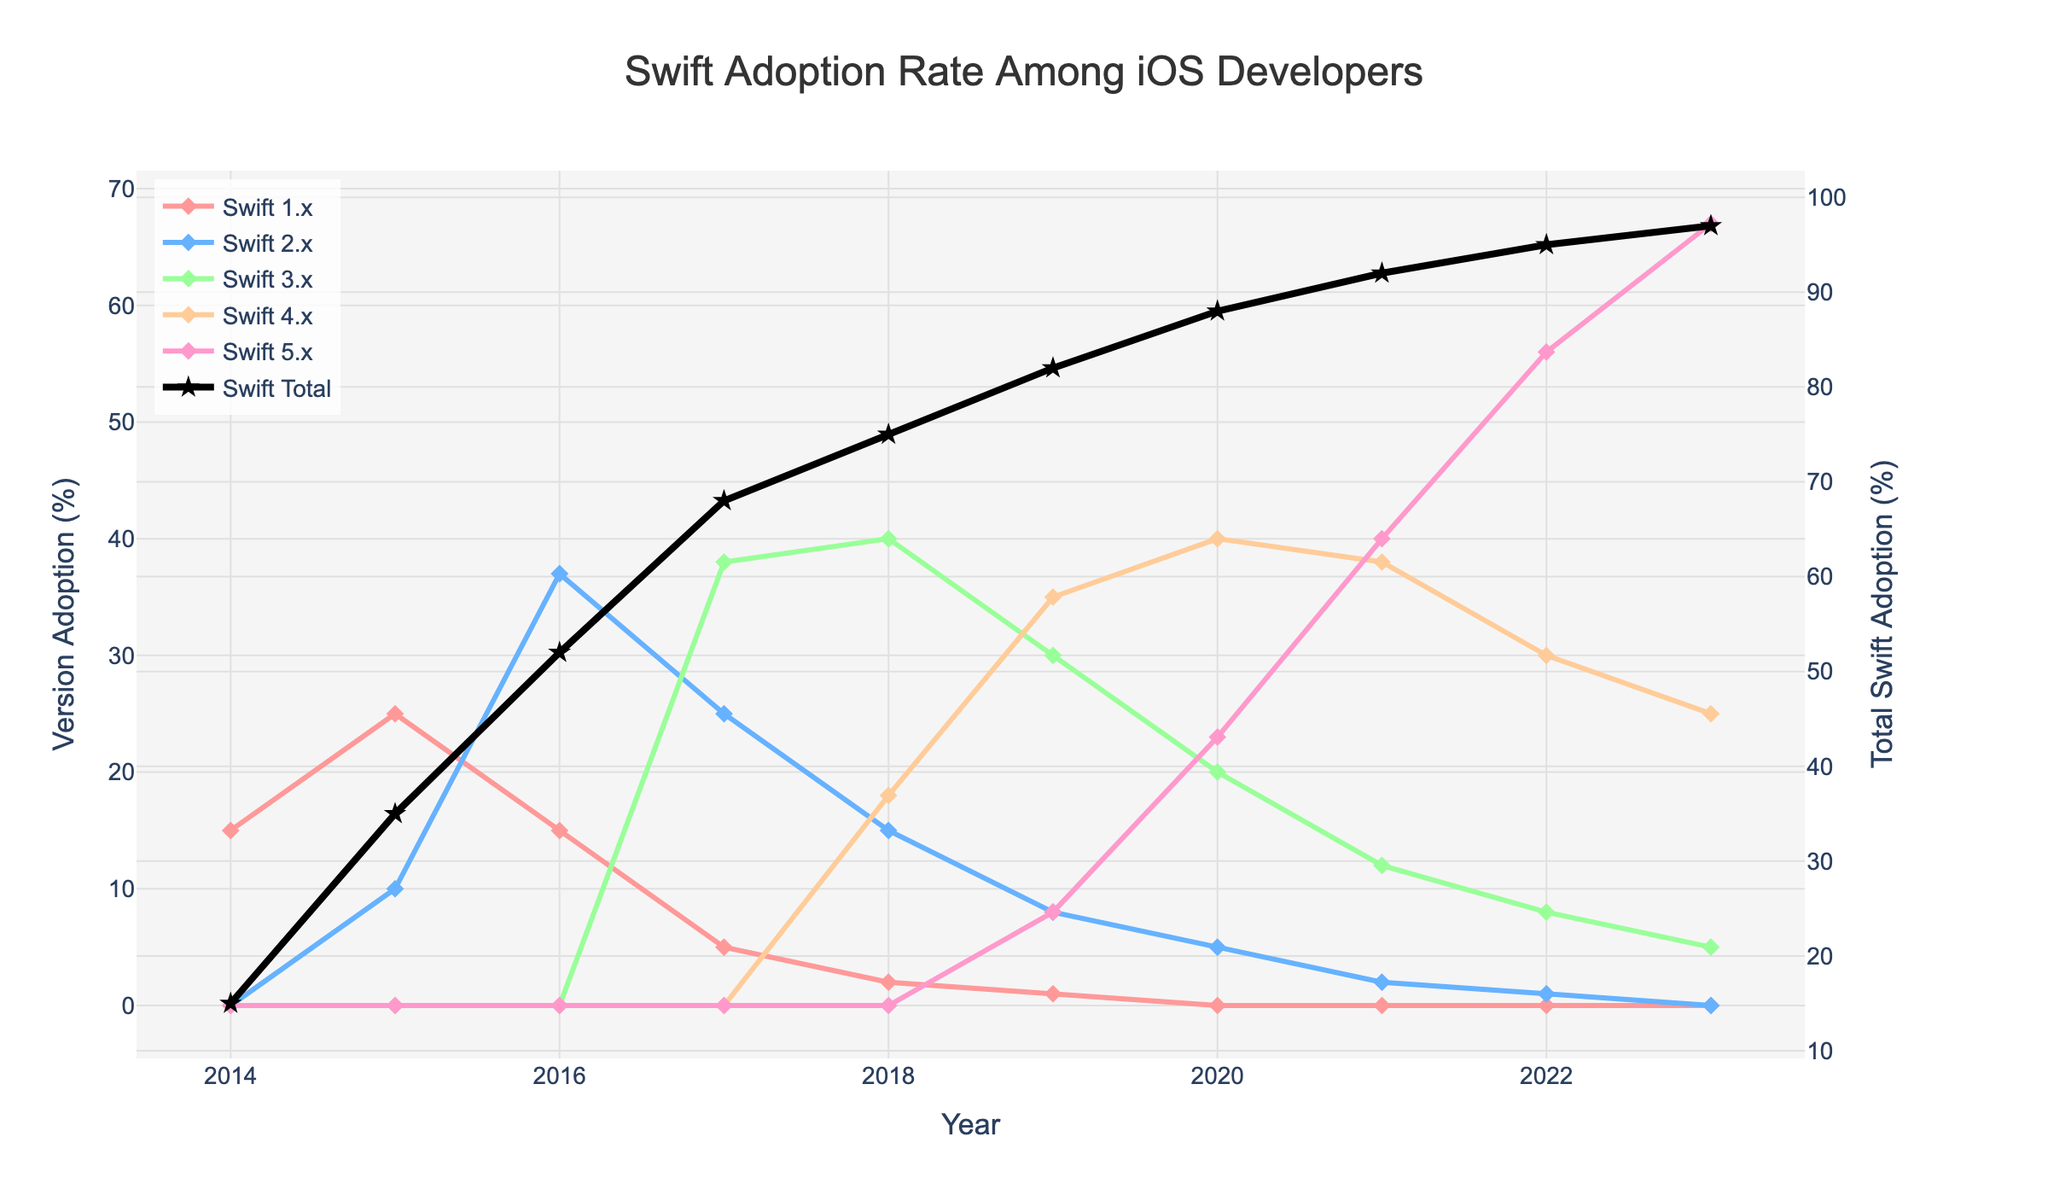What is the total percentage of Swift adoption in 2021? Locate the 'Swift Total' line in the figure and identify its value for the year 2021, which is 92%.
Answer: 92% Which year saw the highest adoption of Swift 3.x? Track the 'Swift 3.x' line and find the year where its value peaks, which shows the highest adoption happened in 2018.
Answer: 2018 In 2015, by how much did the adoption of Swift 2.x increase from 2014? Compare the 'Swift 2.x' line values for 2014 and 2015. Since 'Swift 2.x' was newly introduced in 2015 and was 0 in 2014, the increase is 10% from 0%.
Answer: 10% How did total Swift adoption change from 2017 to 2018? Look at the 'Swift Total' values for 2017 and 2018 and find the difference: 75% (2018) - 68% (2017) = 7%.
Answer: Increased by 7% Which Swift version had the least adoption in 2020? By examining the figure for the year 2020, it's clear that 'Swift 2.x' has the least adoption at just 5%.
Answer: Swift 2.x What is the difference in adoption percentages between Swift 4.x and Swift 5.x in 2023? Locate the values for 'Swift 4.x' and 'Swift 5.x' in 2023 and calculate the difference: 67% (Swift 5.x) - 25% (Swift 4.x) = 42%.
Answer: 42% Did Swift 1.x see any adoption increase after 2016? Observe the 'Swift 1.x' line from 2016 onwards, and notice that its adoption continually decreases, resulting in 0% by 2020.
Answer: No Among the Swift versions, which saw the highest adoption in 2019? In the year 2019 on the figure, 'Swift 4.x' demonstrates the highest adoption percentage at 35%.
Answer: Swift 4.x From 2018 to 2023, how did the total Swift adoption trend? Check the 'Swift Total' line from 2018 to 2023, which shows a continuous upward trend from 75% in 2018 to 97% in 2023.
Answer: Upward trend Compare the adoption of Swift 2.x and Swift 3.x in 2017. Look at the adoption values for 'Swift 2.x' and 'Swift 3.x' in 2017; 'Swift 2.x' is at 25% while 'Swift 3.x' is at 38%.
Answer: Swift 3.x is higher 